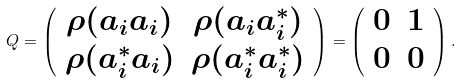Convert formula to latex. <formula><loc_0><loc_0><loc_500><loc_500>Q = \left ( \begin{array} { c c c } \rho ( a _ { i } a _ { i } ) & \rho ( a _ { i } a ^ { * } _ { i } ) \\ \rho ( a ^ { * } _ { i } a _ { i } ) & \rho ( a ^ { * } _ { i } a ^ { * } _ { i } ) \end{array} \right ) = \left ( \begin{array} { c c c } 0 & 1 \\ 0 & 0 \end{array} \right ) .</formula> 